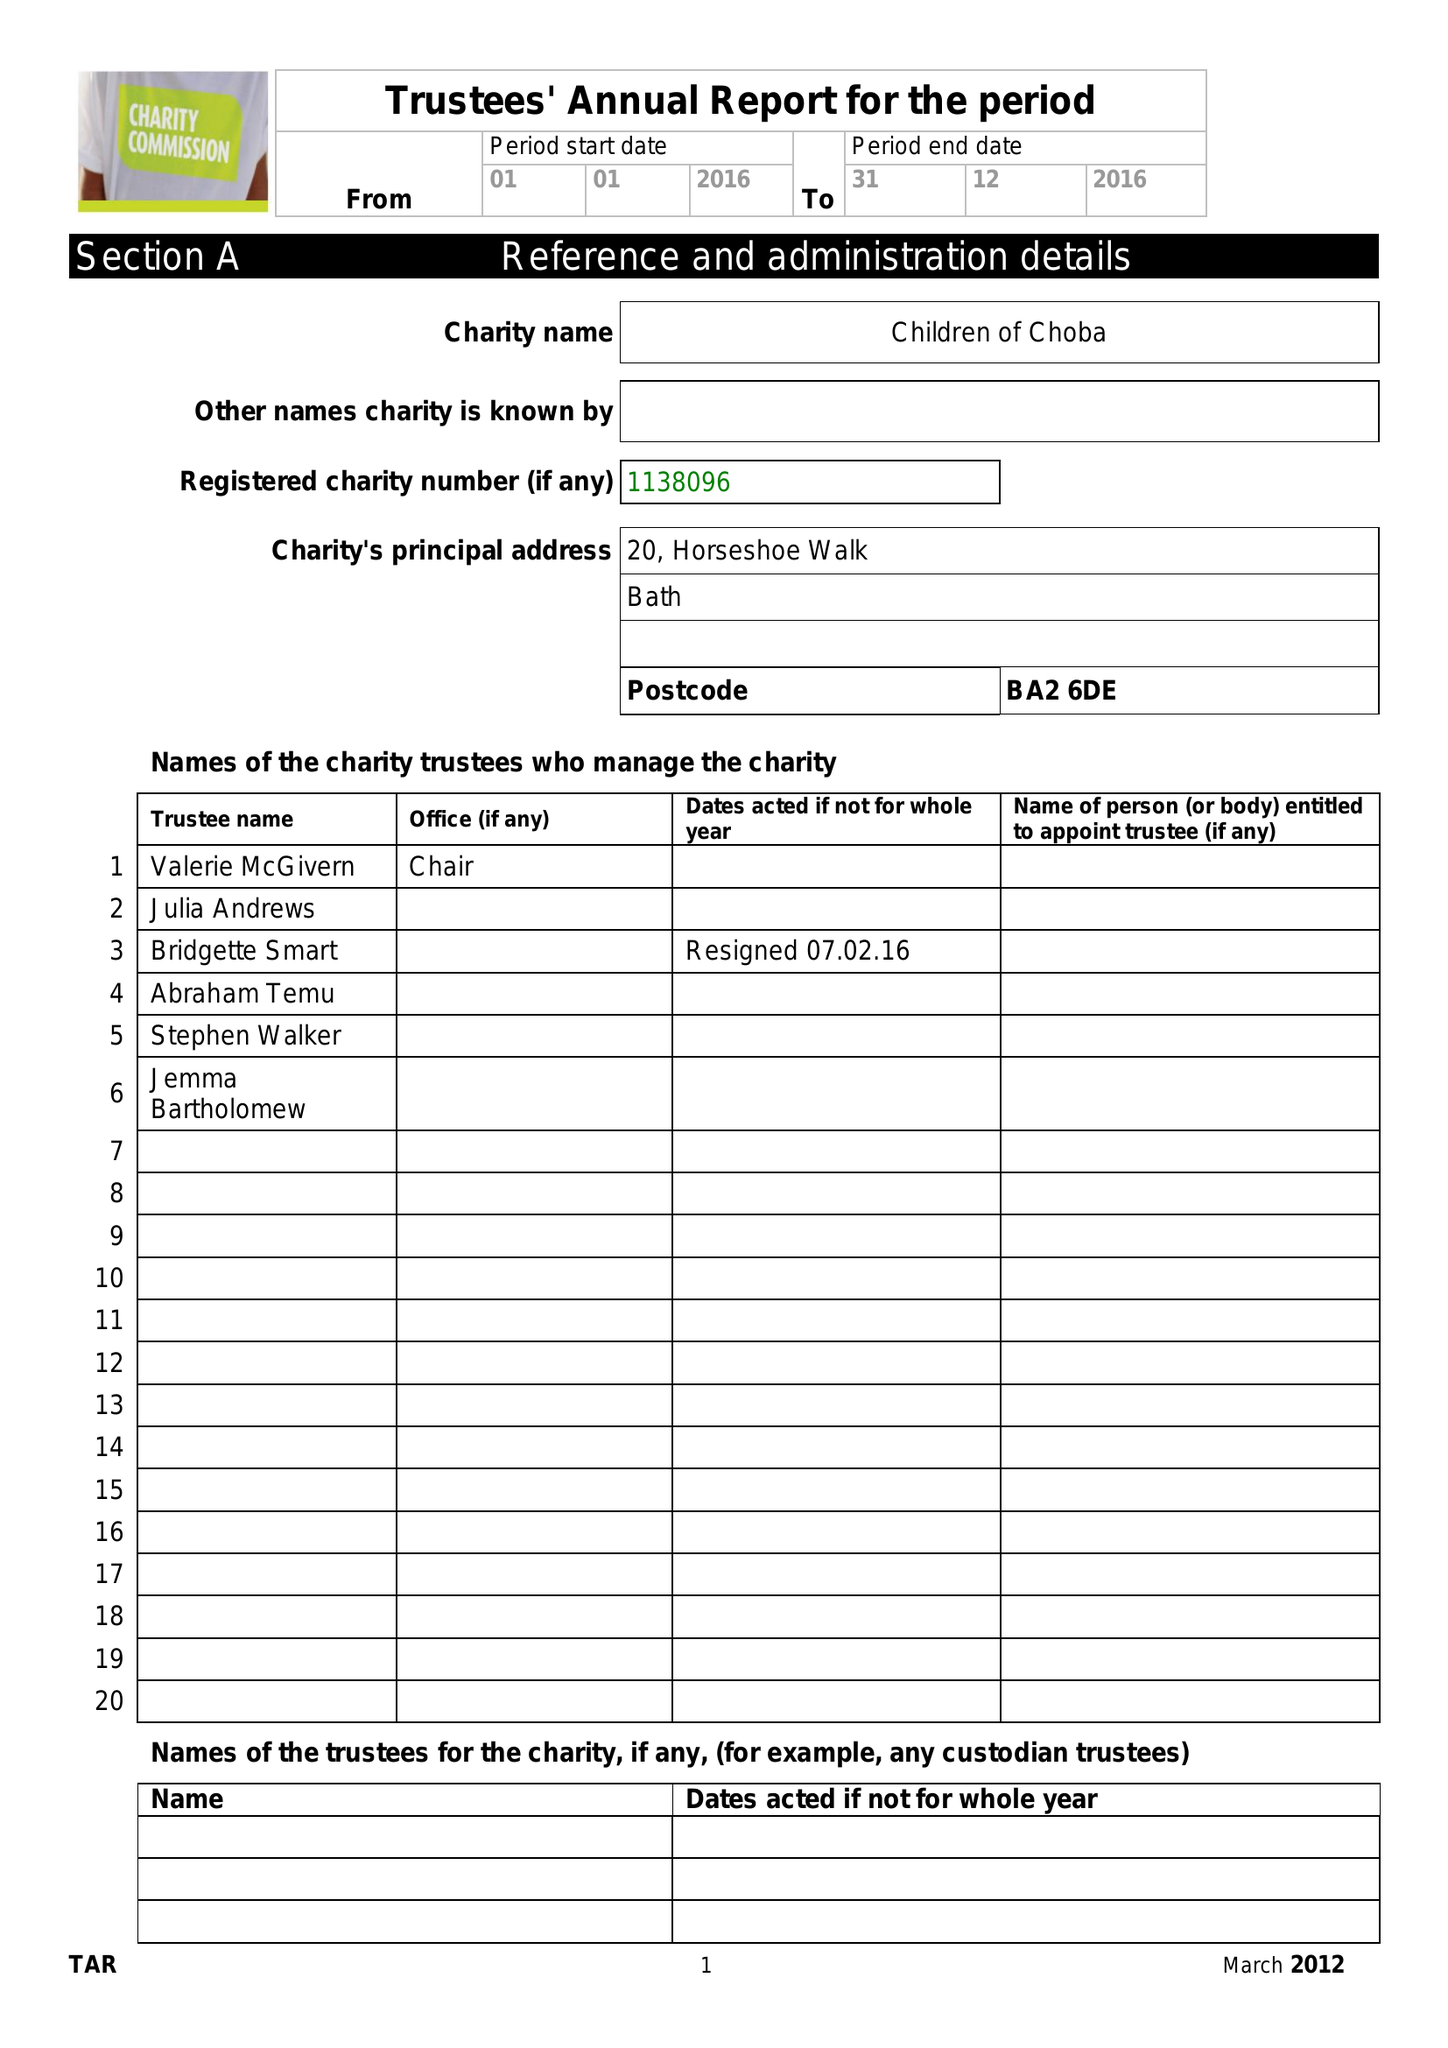What is the value for the address__street_line?
Answer the question using a single word or phrase. 20 HORSESHOE WALK 